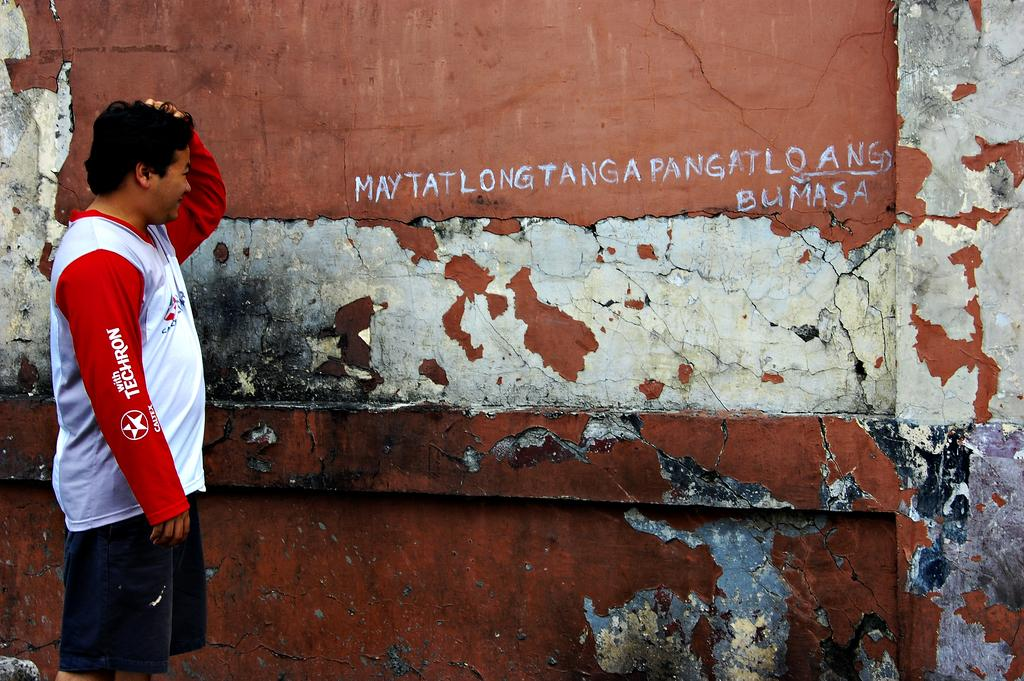<image>
Describe the image concisely. Young man wearing the Techron shirt reads the wall. 